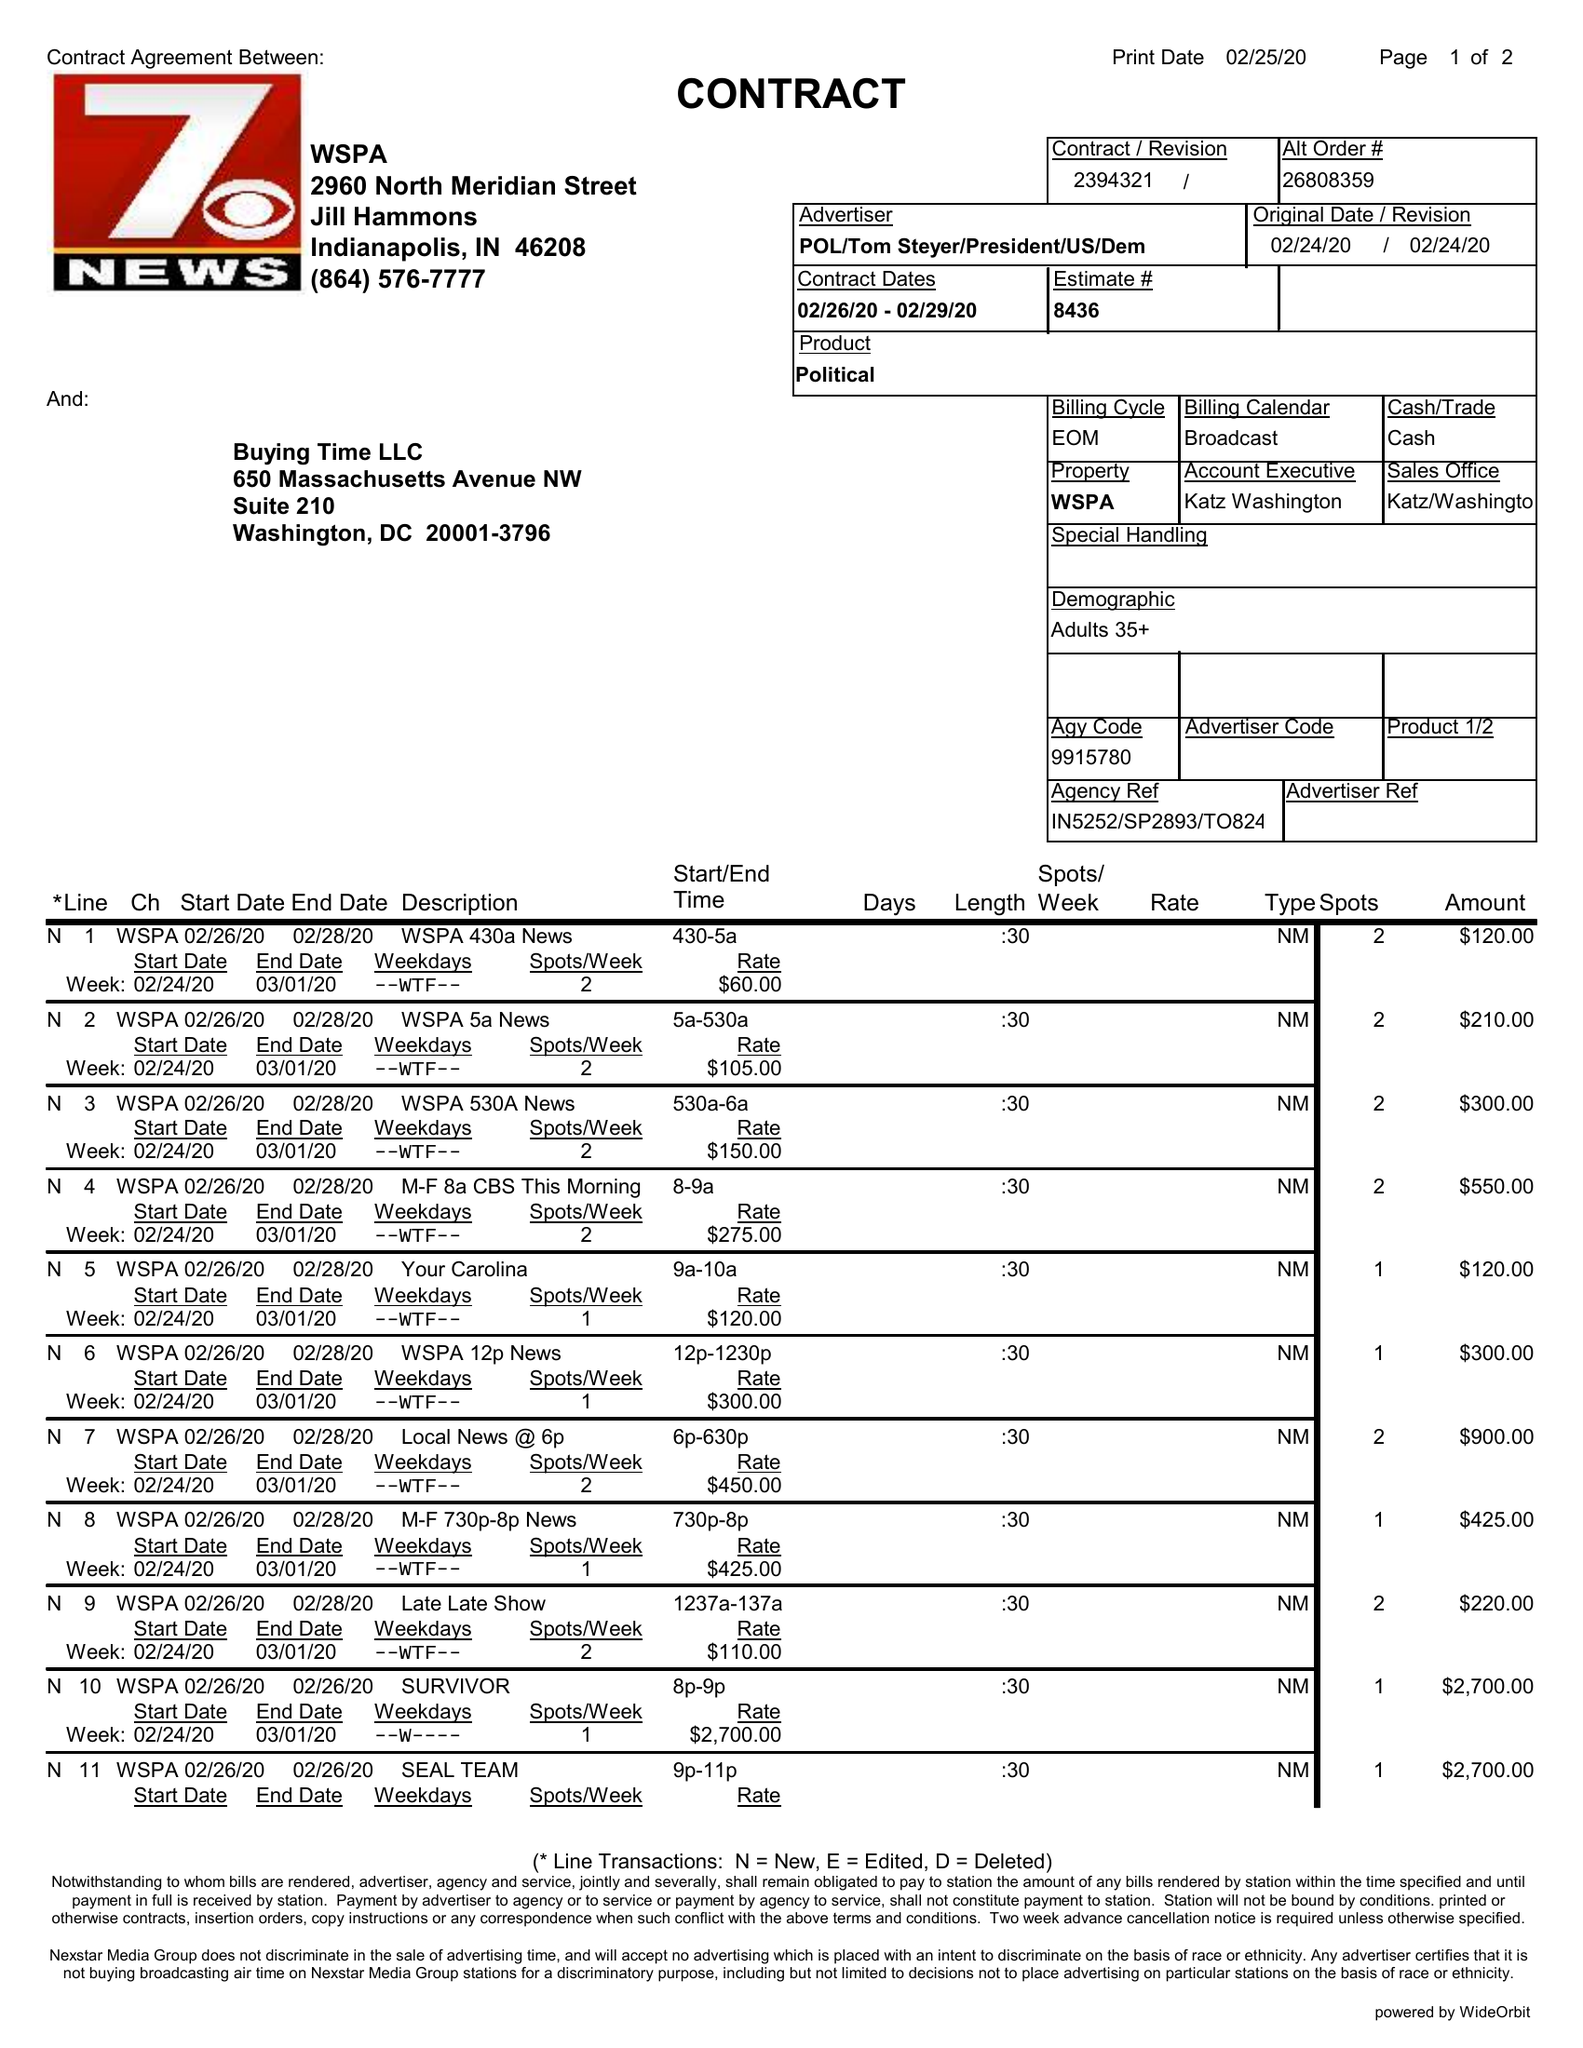What is the value for the advertiser?
Answer the question using a single word or phrase. POL/TOMSTEYER/PRESIDENT/US/DEM 